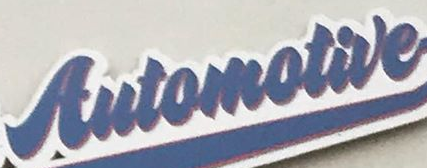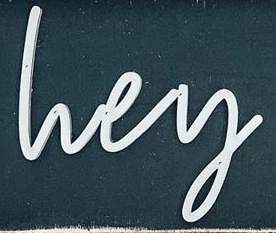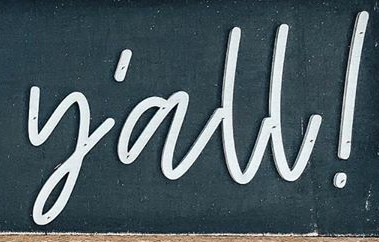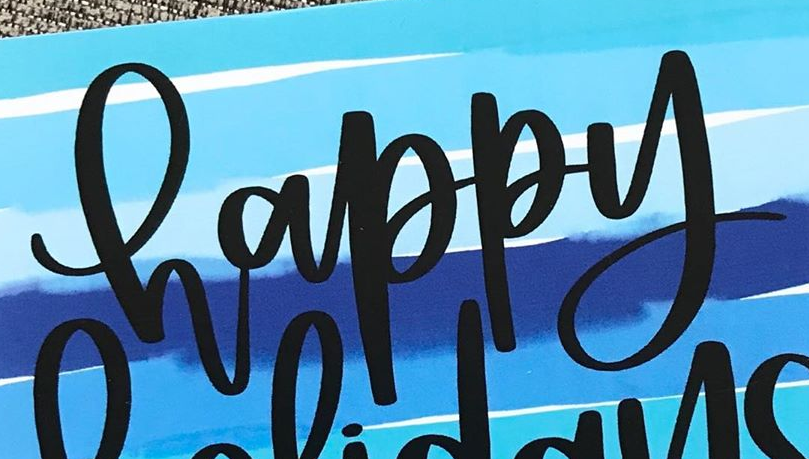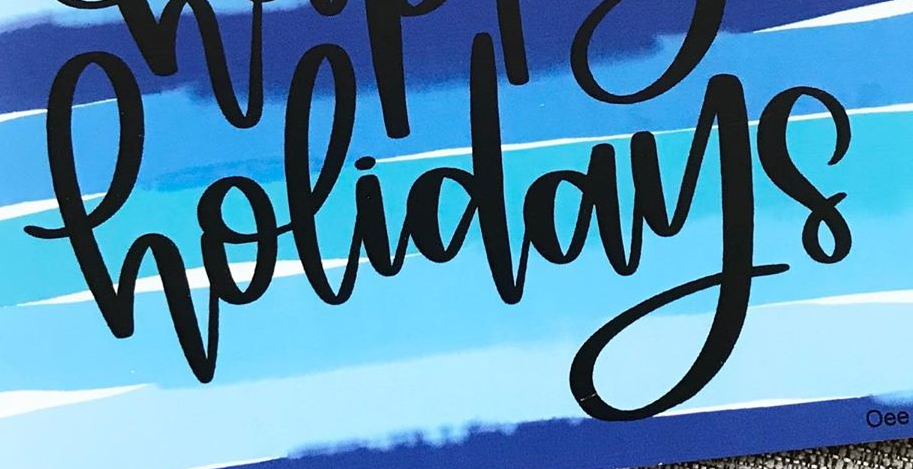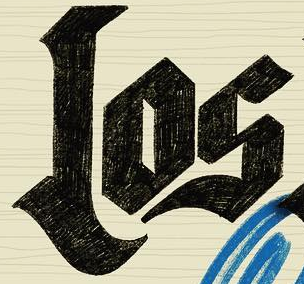What text appears in these images from left to right, separated by a semicolon? Automotive; lvey; y'all!; happy; holidays; Los 